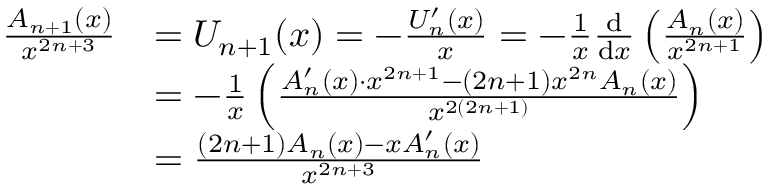Convert formula to latex. <formula><loc_0><loc_0><loc_500><loc_500>{ \begin{array} { r l } { { \frac { A _ { n + 1 } ( x ) } { x ^ { 2 n + 3 } } } } & { = U _ { n + 1 } ( x ) = - { \frac { U _ { n } ^ { \prime } ( x ) } { x } } = - { \frac { 1 } { x } } { \frac { d } { d x } } \left ( { \frac { A _ { n } ( x ) } { x ^ { 2 n + 1 } } } \right ) } \\ & { = - { \frac { 1 } { x } } \left ( { \frac { A _ { n } ^ { \prime } ( x ) \cdot x ^ { 2 n + 1 } - ( 2 n + 1 ) x ^ { 2 n } A _ { n } ( x ) } { x ^ { 2 ( 2 n + 1 ) } } } \right ) } \\ & { = { \frac { ( 2 n + 1 ) A _ { n } ( x ) - x A _ { n } ^ { \prime } ( x ) } { x ^ { 2 n + 3 } } } } \end{array} }</formula> 